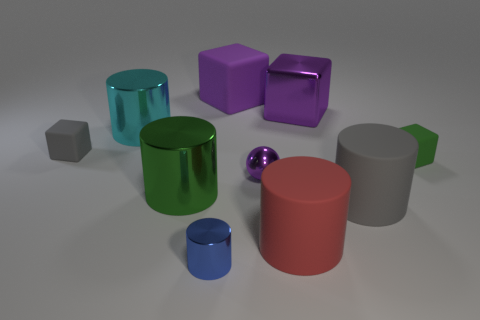Do the tiny cube that is to the left of the tiny blue object and the tiny blue cylinder have the same material? Based on the image provided, the tiny cube to the left of the tiny blue object possesses a matte finish, while the tiny blue cylinder appears to have a glossy surface. Therefore, they do not share the same material properties. 